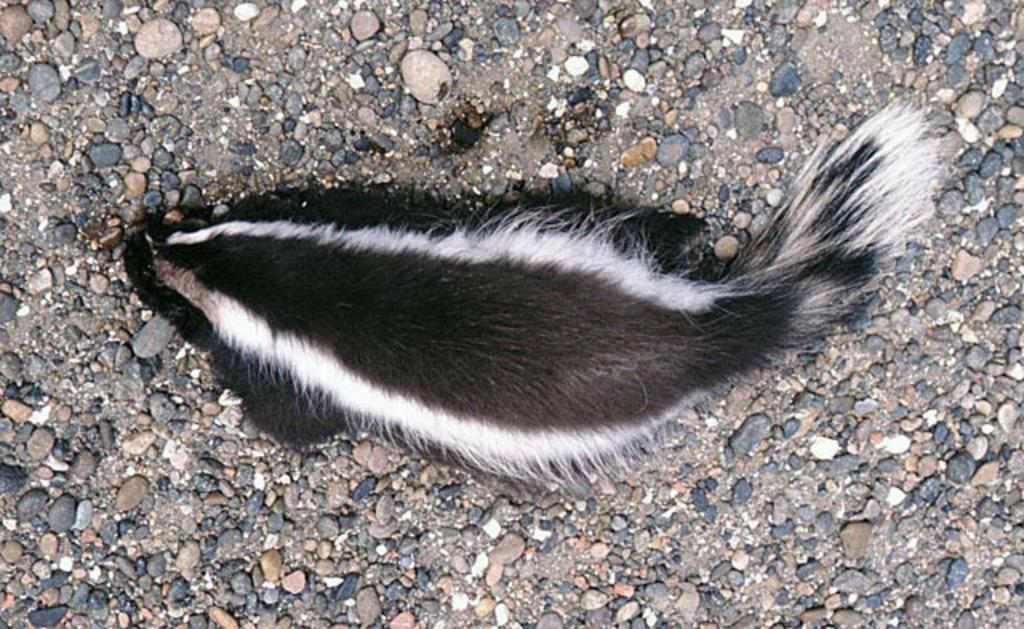What type of animal is in the image? There is a striped skunk in the image. What else can be seen in the image besides the skunk? There are stones in the image. What type of sound does the cup make in the image? There is no cup present in the image, so it cannot make any sound. 